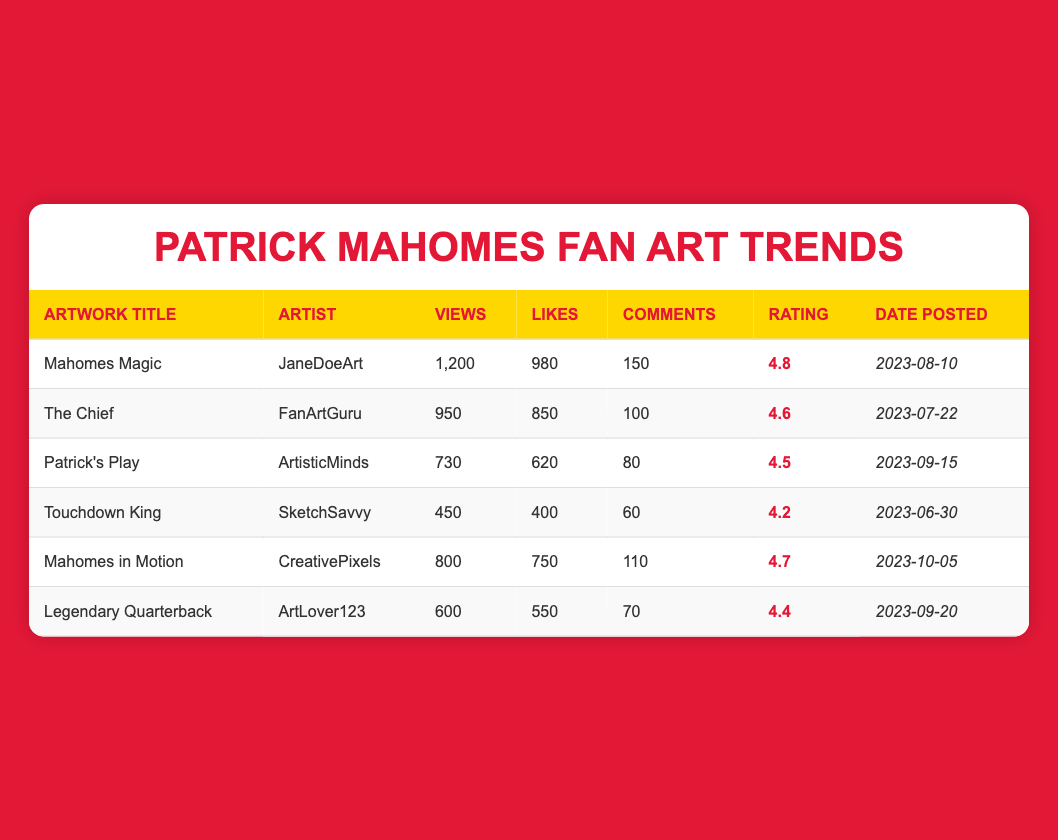What is the highest average rating in the table? Examining the "AverageRating" column, we find that "Mahomes Magic" has the highest rating of 4.8.
Answer: 4.8 Which artwork has the most views? By reviewing the "ViewCount" column, "Mahomes Magic" has the highest view count at 1200 views.
Answer: 1200 How many total likes do all the artworks have combined? By summing the likes: 980 + 850 + 620 + 400 + 750 + 550 = 4050. Therefore, the total likes across all artworks is 4050.
Answer: 4050 Was "Touchdown King" able to surpass 500 likes? Looking at the "Likes" column, "Touchdown King" shows a like count of 400, which is less than 500. So the statement is false.
Answer: No Which artwork was posted most recently? By comparing the "DatePosted" column, "Mahomes in Motion" was posted on 2023-10-05, which is the latest date.
Answer: Mahomes in Motion What is the average rating of artworks with more than 700 views? First, identify the relevant artworks: "Mahomes Magic" (4.8), "The Chief" (4.6), "Patrick's Play" (4.5), and "Mahomes in Motion" (4.7). Summing these ratings gives 4.8 + 4.6 + 4.5 + 4.7 = 19.6. There are 4 artworks, so the average rating is 19.6 / 4 = 4.9.
Answer: 4.9 Did all the artworks receive an average rating of 4.5 or higher? Analyzing the "AverageRating" column shows that "Touchdown King" has a rating of 4.2, which is below 4.5. Therefore, not all artworks meet the criteria.
Answer: No How many comments did "Patrick's Play" receive? From the "Comments" column, "Patrick's Play" shows 80 comments.
Answer: 80 What percentage of total views did "The Chief" achieve compared to the total views of all artworks? The total views are 1200 + 950 + 730 + 450 + 800 + 600 = 3820. "The Chief" has 950 views. The percentage is (950 / 3820) * 100 = 24.87%.
Answer: 24.87% 